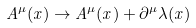Convert formula to latex. <formula><loc_0><loc_0><loc_500><loc_500>A ^ { \mu } ( x ) \to A ^ { \mu } ( x ) + \partial ^ { \mu } \lambda ( x )</formula> 